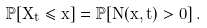<formula> <loc_0><loc_0><loc_500><loc_500>\mathbb { P } [ X _ { t } \leq x ] = \mathbb { P } [ N ( x , t ) > 0 ] \, .</formula> 